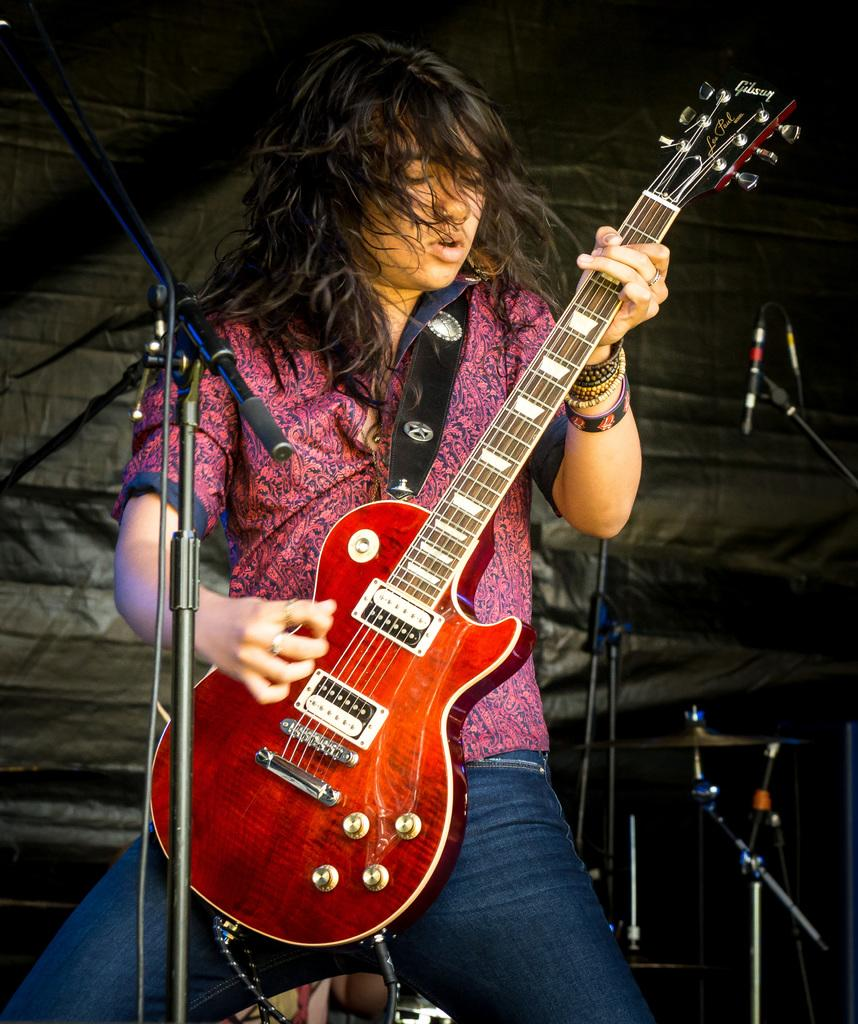Who is the main subject in the image? There is a woman in the image. What is the woman doing in the image? The woman is playing a guitar. Can you describe the guitar? The guitar is red in color. What else can be seen in the background of the image? There are musical instruments in the background. What might the woman be using to amplify her voice? There is a microphone in the image. What type of needle is the woman using to sew a dress in the image? There is no needle or dress present in the image; the woman is playing a guitar. 